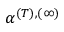<formula> <loc_0><loc_0><loc_500><loc_500>\alpha ^ { ( T ) , ( \infty ) }</formula> 